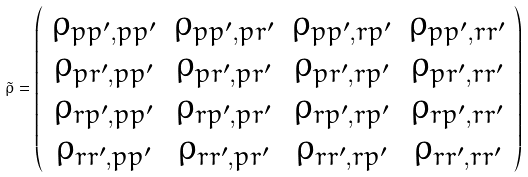<formula> <loc_0><loc_0><loc_500><loc_500>\tilde { \rho } = \left ( \begin{array} { c c c c } \rho _ { p p ^ { \prime } , p p ^ { \prime } } & \rho _ { p p ^ { \prime } , p r ^ { \prime } } & \rho _ { p p ^ { \prime } , r p ^ { \prime } } & \rho _ { p p ^ { \prime } , r r ^ { \prime } } \\ \rho _ { p r ^ { \prime } , p p ^ { \prime } } & \rho _ { p r ^ { \prime } , p r ^ { \prime } } & \rho _ { p r ^ { \prime } , r p ^ { \prime } } & \rho _ { p r ^ { \prime } , r r ^ { \prime } } \\ \rho _ { r p ^ { \prime } , p p ^ { \prime } } & \rho _ { r p ^ { \prime } , p r ^ { \prime } } & \rho _ { r p ^ { \prime } , r p ^ { \prime } } & \rho _ { r p ^ { \prime } , r r ^ { \prime } } \\ \rho _ { r r ^ { \prime } , p p ^ { \prime } } & \rho _ { r r ^ { \prime } , p r ^ { \prime } } & \rho _ { r r ^ { \prime } , r p ^ { \prime } } & \rho _ { r r ^ { \prime } , r r ^ { \prime } } \end{array} \right )</formula> 